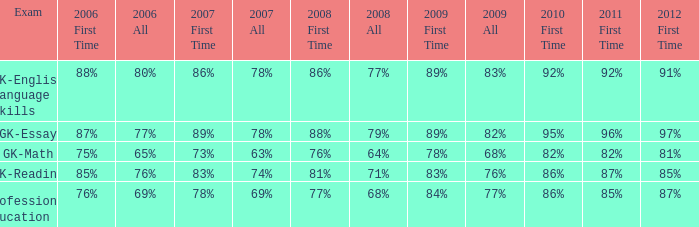Would you mind parsing the complete table? {'header': ['Exam', '2006 First Time', '2006 All', '2007 First Time', '2007 All', '2008 First Time', '2008 All', '2009 First Time', '2009 All', '2010 First Time', '2011 First Time', '2012 First Time'], 'rows': [['GK-English Language Skills', '88%', '80%', '86%', '78%', '86%', '77%', '89%', '83%', '92%', '92%', '91%'], ['GK-Essay', '87%', '77%', '89%', '78%', '88%', '79%', '89%', '82%', '95%', '96%', '97%'], ['GK-Math', '75%', '65%', '73%', '63%', '76%', '64%', '78%', '68%', '82%', '82%', '81%'], ['GK-Reading', '85%', '76%', '83%', '74%', '81%', '71%', '83%', '76%', '86%', '87%', '85%'], ['Professional Education', '76%', '69%', '78%', '69%', '77%', '68%', '84%', '77%', '86%', '85%', '87%']]} What is the rate for all in 2008 when all in 2007 was 69%? 68%. 